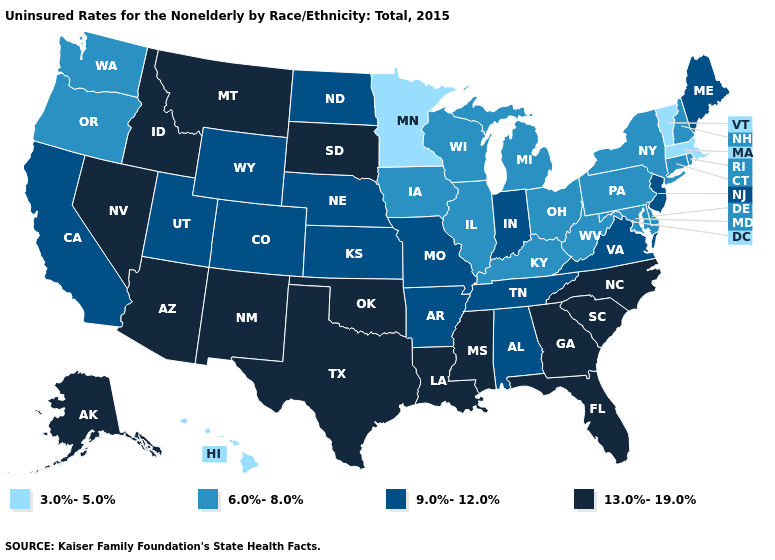What is the lowest value in the USA?
Short answer required. 3.0%-5.0%. What is the lowest value in the USA?
Keep it brief. 3.0%-5.0%. Name the states that have a value in the range 6.0%-8.0%?
Keep it brief. Connecticut, Delaware, Illinois, Iowa, Kentucky, Maryland, Michigan, New Hampshire, New York, Ohio, Oregon, Pennsylvania, Rhode Island, Washington, West Virginia, Wisconsin. Which states have the highest value in the USA?
Write a very short answer. Alaska, Arizona, Florida, Georgia, Idaho, Louisiana, Mississippi, Montana, Nevada, New Mexico, North Carolina, Oklahoma, South Carolina, South Dakota, Texas. Does Maine have the same value as Michigan?
Keep it brief. No. What is the value of Mississippi?
Give a very brief answer. 13.0%-19.0%. What is the value of Delaware?
Answer briefly. 6.0%-8.0%. Name the states that have a value in the range 13.0%-19.0%?
Write a very short answer. Alaska, Arizona, Florida, Georgia, Idaho, Louisiana, Mississippi, Montana, Nevada, New Mexico, North Carolina, Oklahoma, South Carolina, South Dakota, Texas. Among the states that border Louisiana , which have the lowest value?
Short answer required. Arkansas. What is the highest value in the South ?
Concise answer only. 13.0%-19.0%. Does Ohio have a lower value than Alaska?
Answer briefly. Yes. Among the states that border New York , does New Jersey have the highest value?
Be succinct. Yes. What is the lowest value in states that border Georgia?
Short answer required. 9.0%-12.0%. Does the first symbol in the legend represent the smallest category?
Quick response, please. Yes. 